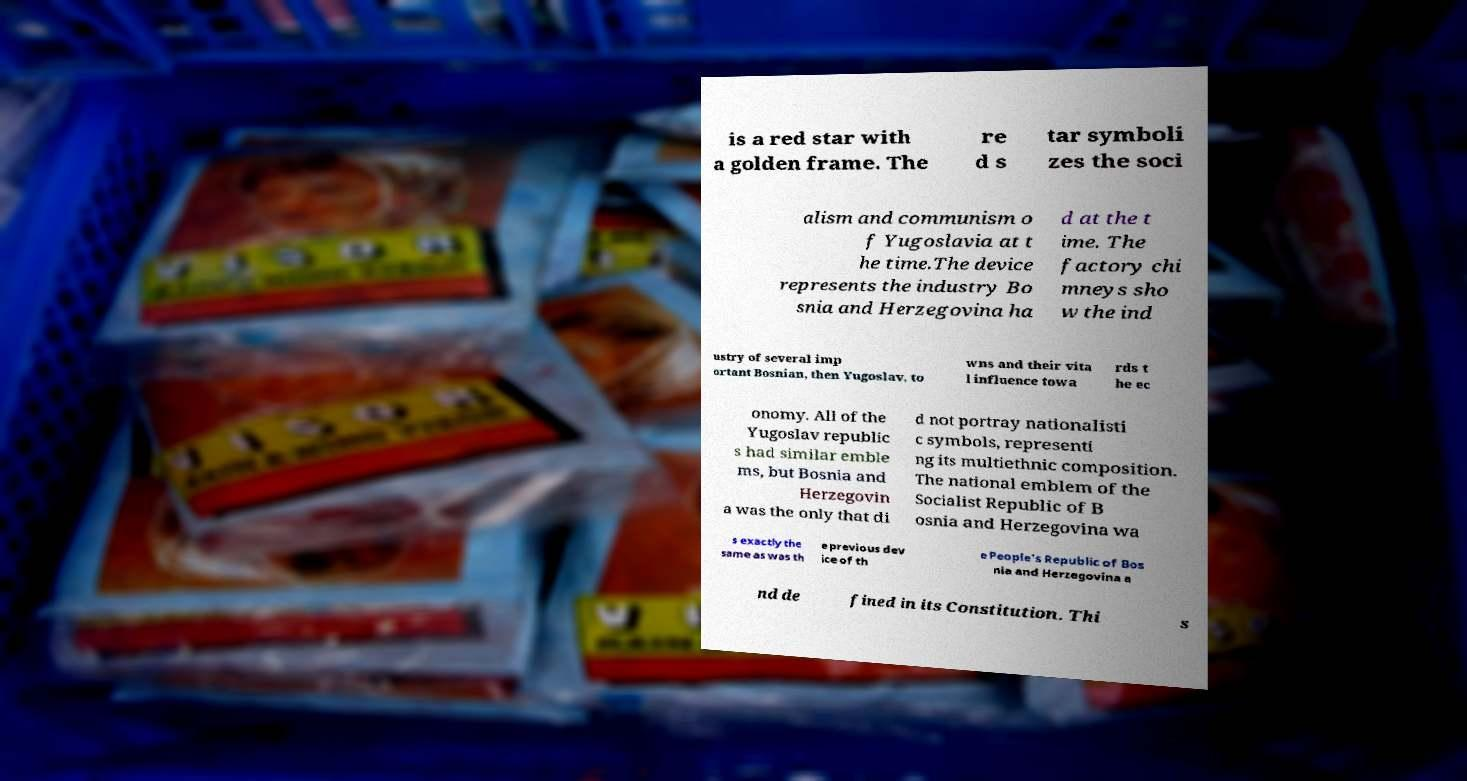What messages or text are displayed in this image? I need them in a readable, typed format. is a red star with a golden frame. The re d s tar symboli zes the soci alism and communism o f Yugoslavia at t he time.The device represents the industry Bo snia and Herzegovina ha d at the t ime. The factory chi mneys sho w the ind ustry of several imp ortant Bosnian, then Yugoslav, to wns and their vita l influence towa rds t he ec onomy. All of the Yugoslav republic s had similar emble ms, but Bosnia and Herzegovin a was the only that di d not portray nationalisti c symbols, representi ng its multiethnic composition. The national emblem of the Socialist Republic of B osnia and Herzegovina wa s exactly the same as was th e previous dev ice of th e People's Republic of Bos nia and Herzegovina a nd de fined in its Constitution. Thi s 